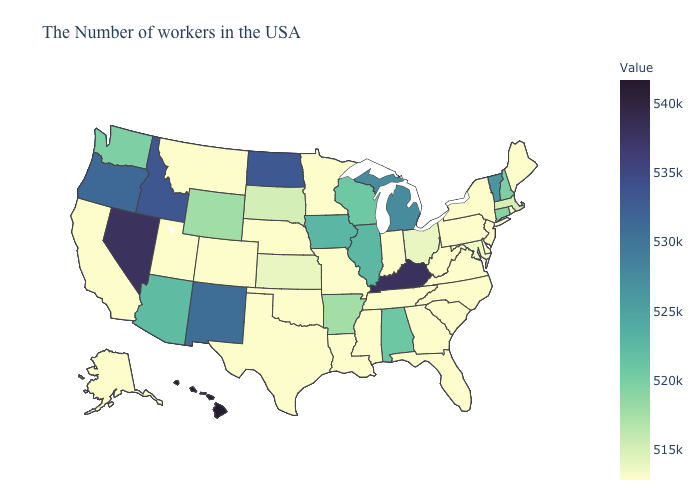Is the legend a continuous bar?
Concise answer only. Yes. Does Hawaii have the highest value in the USA?
Write a very short answer. Yes. Among the states that border Arizona , which have the lowest value?
Be succinct. Colorado, Utah, California. Which states hav the highest value in the Northeast?
Answer briefly. Vermont. Does the map have missing data?
Be succinct. No. Does Hawaii have the highest value in the USA?
Keep it brief. Yes. Which states have the lowest value in the USA?
Be succinct. Maine, Rhode Island, New York, New Jersey, Delaware, Pennsylvania, Virginia, North Carolina, South Carolina, West Virginia, Florida, Georgia, Indiana, Tennessee, Mississippi, Louisiana, Missouri, Minnesota, Nebraska, Oklahoma, Texas, Colorado, Utah, Montana, California, Alaska. Does Hawaii have the highest value in the USA?
Write a very short answer. Yes. 